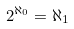Convert formula to latex. <formula><loc_0><loc_0><loc_500><loc_500>2 ^ { \aleph _ { 0 } } = \aleph _ { 1 }</formula> 